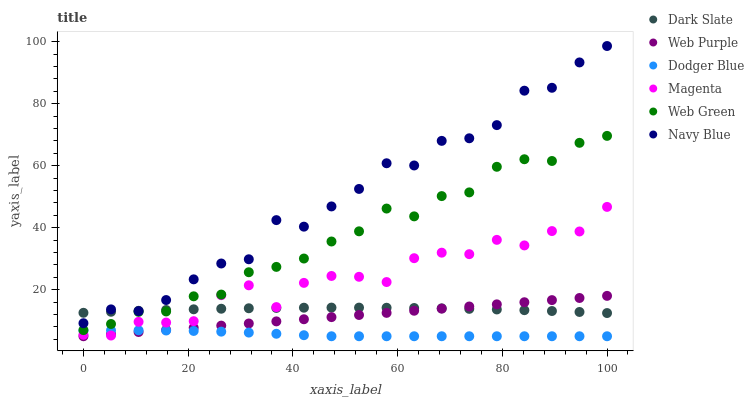Does Dodger Blue have the minimum area under the curve?
Answer yes or no. Yes. Does Navy Blue have the maximum area under the curve?
Answer yes or no. Yes. Does Web Green have the minimum area under the curve?
Answer yes or no. No. Does Web Green have the maximum area under the curve?
Answer yes or no. No. Is Web Purple the smoothest?
Answer yes or no. Yes. Is Navy Blue the roughest?
Answer yes or no. Yes. Is Web Green the smoothest?
Answer yes or no. No. Is Web Green the roughest?
Answer yes or no. No. Does Web Purple have the lowest value?
Answer yes or no. Yes. Does Web Green have the lowest value?
Answer yes or no. No. Does Navy Blue have the highest value?
Answer yes or no. Yes. Does Web Green have the highest value?
Answer yes or no. No. Is Web Purple less than Web Green?
Answer yes or no. Yes. Is Navy Blue greater than Web Green?
Answer yes or no. Yes. Does Dark Slate intersect Magenta?
Answer yes or no. Yes. Is Dark Slate less than Magenta?
Answer yes or no. No. Is Dark Slate greater than Magenta?
Answer yes or no. No. Does Web Purple intersect Web Green?
Answer yes or no. No. 